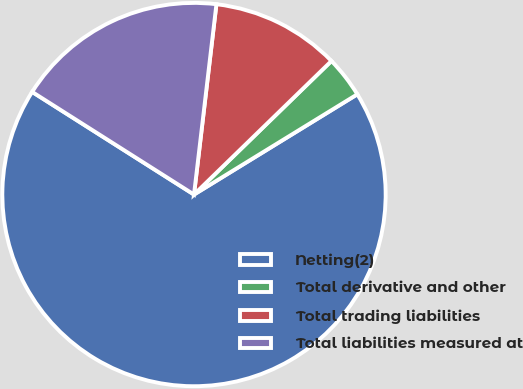Convert chart to OTSL. <chart><loc_0><loc_0><loc_500><loc_500><pie_chart><fcel>Netting(2)<fcel>Total derivative and other<fcel>Total trading liabilities<fcel>Total liabilities measured at<nl><fcel>67.76%<fcel>3.51%<fcel>10.86%<fcel>17.87%<nl></chart> 